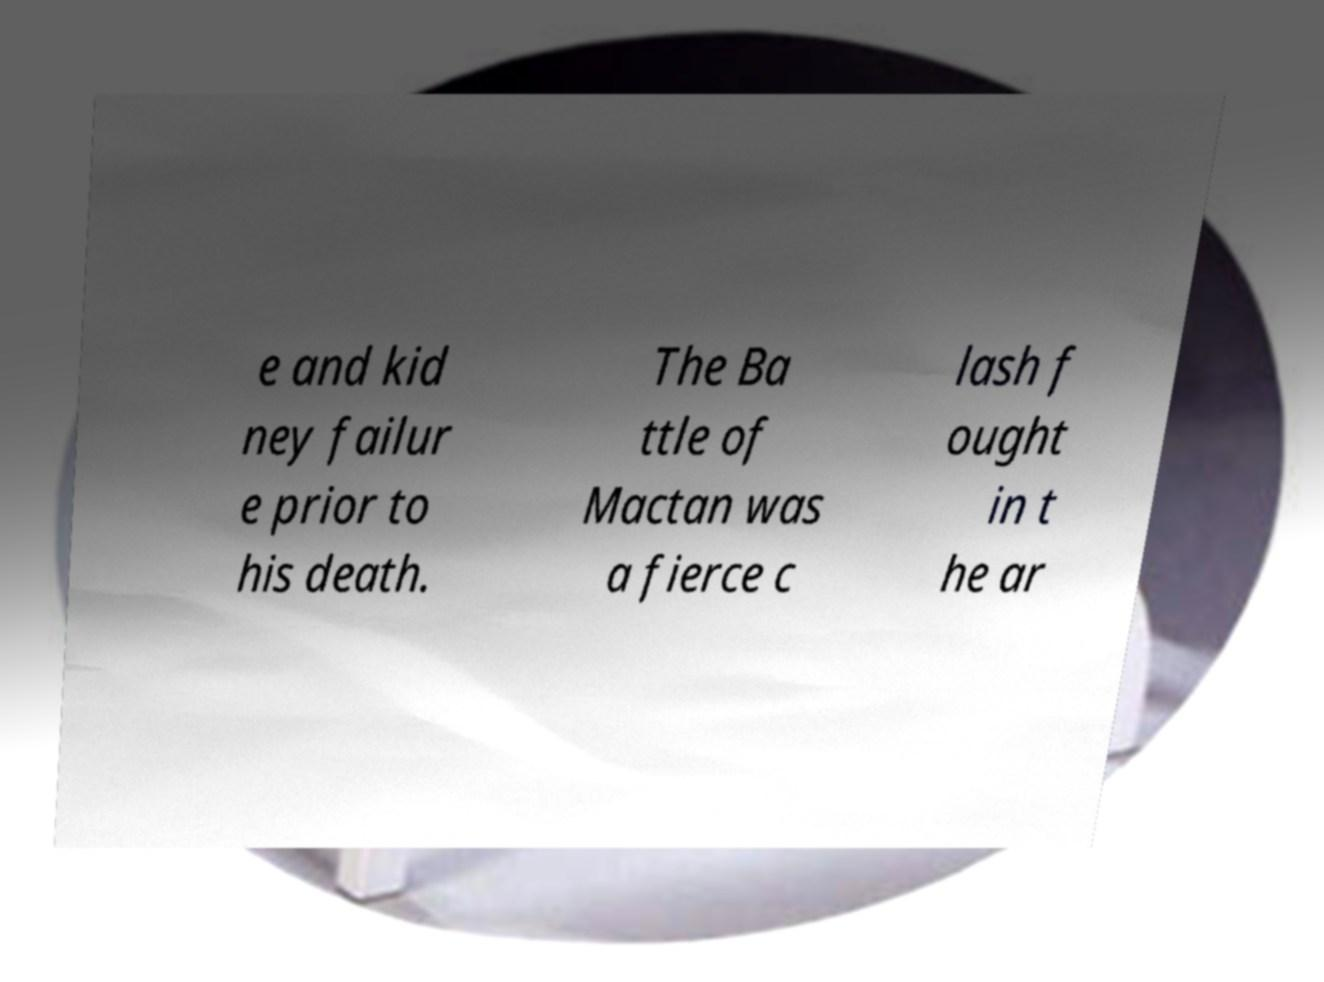What messages or text are displayed in this image? I need them in a readable, typed format. e and kid ney failur e prior to his death. The Ba ttle of Mactan was a fierce c lash f ought in t he ar 